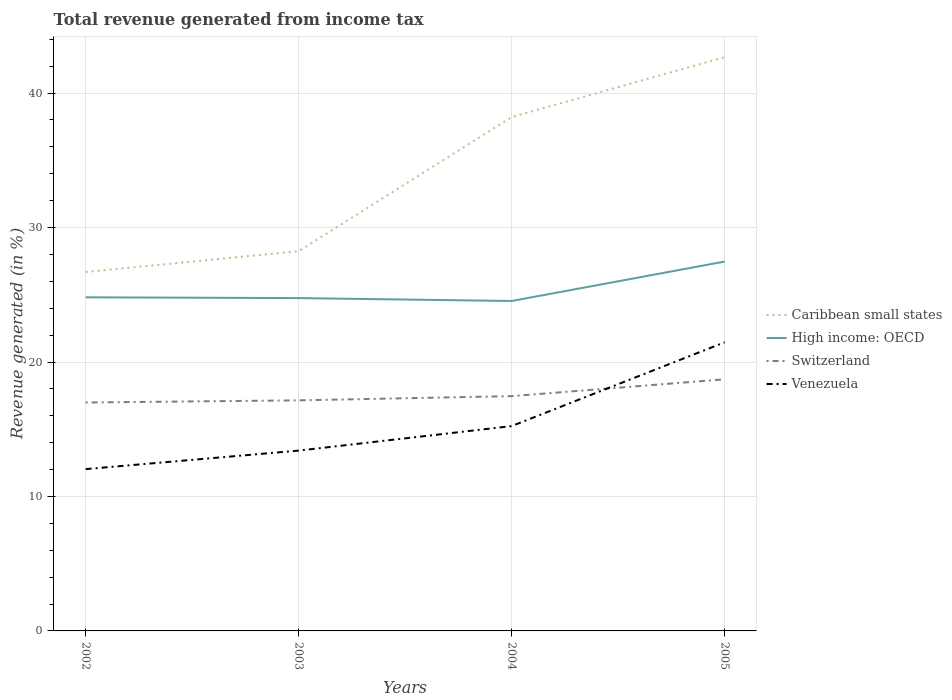How many different coloured lines are there?
Give a very brief answer. 4. Is the number of lines equal to the number of legend labels?
Ensure brevity in your answer.  Yes. Across all years, what is the maximum total revenue generated in Switzerland?
Offer a terse response. 16.99. What is the total total revenue generated in Venezuela in the graph?
Keep it short and to the point. -6.23. What is the difference between the highest and the second highest total revenue generated in Caribbean small states?
Offer a terse response. 15.98. Are the values on the major ticks of Y-axis written in scientific E-notation?
Your answer should be compact. No. Does the graph contain any zero values?
Your answer should be compact. No. Does the graph contain grids?
Give a very brief answer. Yes. How many legend labels are there?
Make the answer very short. 4. What is the title of the graph?
Your answer should be compact. Total revenue generated from income tax. Does "Mauritania" appear as one of the legend labels in the graph?
Your answer should be very brief. No. What is the label or title of the X-axis?
Provide a short and direct response. Years. What is the label or title of the Y-axis?
Keep it short and to the point. Revenue generated (in %). What is the Revenue generated (in %) in Caribbean small states in 2002?
Make the answer very short. 26.7. What is the Revenue generated (in %) in High income: OECD in 2002?
Make the answer very short. 24.81. What is the Revenue generated (in %) of Switzerland in 2002?
Ensure brevity in your answer.  16.99. What is the Revenue generated (in %) in Venezuela in 2002?
Give a very brief answer. 12.03. What is the Revenue generated (in %) of Caribbean small states in 2003?
Provide a succinct answer. 28.24. What is the Revenue generated (in %) in High income: OECD in 2003?
Offer a terse response. 24.75. What is the Revenue generated (in %) of Switzerland in 2003?
Ensure brevity in your answer.  17.15. What is the Revenue generated (in %) of Venezuela in 2003?
Offer a terse response. 13.41. What is the Revenue generated (in %) in Caribbean small states in 2004?
Ensure brevity in your answer.  38.22. What is the Revenue generated (in %) of High income: OECD in 2004?
Keep it short and to the point. 24.54. What is the Revenue generated (in %) of Switzerland in 2004?
Offer a very short reply. 17.46. What is the Revenue generated (in %) in Venezuela in 2004?
Provide a succinct answer. 15.23. What is the Revenue generated (in %) in Caribbean small states in 2005?
Provide a succinct answer. 42.67. What is the Revenue generated (in %) in High income: OECD in 2005?
Your response must be concise. 27.47. What is the Revenue generated (in %) of Switzerland in 2005?
Give a very brief answer. 18.71. What is the Revenue generated (in %) in Venezuela in 2005?
Your answer should be very brief. 21.46. Across all years, what is the maximum Revenue generated (in %) in Caribbean small states?
Make the answer very short. 42.67. Across all years, what is the maximum Revenue generated (in %) of High income: OECD?
Offer a terse response. 27.47. Across all years, what is the maximum Revenue generated (in %) of Switzerland?
Provide a succinct answer. 18.71. Across all years, what is the maximum Revenue generated (in %) in Venezuela?
Make the answer very short. 21.46. Across all years, what is the minimum Revenue generated (in %) of Caribbean small states?
Your response must be concise. 26.7. Across all years, what is the minimum Revenue generated (in %) of High income: OECD?
Make the answer very short. 24.54. Across all years, what is the minimum Revenue generated (in %) of Switzerland?
Your answer should be compact. 16.99. Across all years, what is the minimum Revenue generated (in %) in Venezuela?
Keep it short and to the point. 12.03. What is the total Revenue generated (in %) of Caribbean small states in the graph?
Your answer should be compact. 135.83. What is the total Revenue generated (in %) of High income: OECD in the graph?
Give a very brief answer. 101.57. What is the total Revenue generated (in %) in Switzerland in the graph?
Give a very brief answer. 70.31. What is the total Revenue generated (in %) of Venezuela in the graph?
Your answer should be compact. 62.14. What is the difference between the Revenue generated (in %) in Caribbean small states in 2002 and that in 2003?
Your answer should be very brief. -1.55. What is the difference between the Revenue generated (in %) of High income: OECD in 2002 and that in 2003?
Ensure brevity in your answer.  0.06. What is the difference between the Revenue generated (in %) in Switzerland in 2002 and that in 2003?
Make the answer very short. -0.16. What is the difference between the Revenue generated (in %) in Venezuela in 2002 and that in 2003?
Ensure brevity in your answer.  -1.38. What is the difference between the Revenue generated (in %) of Caribbean small states in 2002 and that in 2004?
Your answer should be very brief. -11.52. What is the difference between the Revenue generated (in %) of High income: OECD in 2002 and that in 2004?
Give a very brief answer. 0.27. What is the difference between the Revenue generated (in %) in Switzerland in 2002 and that in 2004?
Your response must be concise. -0.47. What is the difference between the Revenue generated (in %) of Venezuela in 2002 and that in 2004?
Offer a very short reply. -3.2. What is the difference between the Revenue generated (in %) in Caribbean small states in 2002 and that in 2005?
Your answer should be very brief. -15.98. What is the difference between the Revenue generated (in %) in High income: OECD in 2002 and that in 2005?
Ensure brevity in your answer.  -2.66. What is the difference between the Revenue generated (in %) in Switzerland in 2002 and that in 2005?
Offer a very short reply. -1.72. What is the difference between the Revenue generated (in %) in Venezuela in 2002 and that in 2005?
Ensure brevity in your answer.  -9.43. What is the difference between the Revenue generated (in %) in Caribbean small states in 2003 and that in 2004?
Your answer should be very brief. -9.98. What is the difference between the Revenue generated (in %) of High income: OECD in 2003 and that in 2004?
Keep it short and to the point. 0.22. What is the difference between the Revenue generated (in %) of Switzerland in 2003 and that in 2004?
Give a very brief answer. -0.31. What is the difference between the Revenue generated (in %) in Venezuela in 2003 and that in 2004?
Your answer should be compact. -1.82. What is the difference between the Revenue generated (in %) in Caribbean small states in 2003 and that in 2005?
Provide a succinct answer. -14.43. What is the difference between the Revenue generated (in %) of High income: OECD in 2003 and that in 2005?
Provide a succinct answer. -2.72. What is the difference between the Revenue generated (in %) of Switzerland in 2003 and that in 2005?
Make the answer very short. -1.56. What is the difference between the Revenue generated (in %) in Venezuela in 2003 and that in 2005?
Your answer should be very brief. -8.05. What is the difference between the Revenue generated (in %) of Caribbean small states in 2004 and that in 2005?
Offer a very short reply. -4.45. What is the difference between the Revenue generated (in %) of High income: OECD in 2004 and that in 2005?
Your answer should be very brief. -2.93. What is the difference between the Revenue generated (in %) of Switzerland in 2004 and that in 2005?
Provide a succinct answer. -1.25. What is the difference between the Revenue generated (in %) in Venezuela in 2004 and that in 2005?
Your answer should be very brief. -6.23. What is the difference between the Revenue generated (in %) in Caribbean small states in 2002 and the Revenue generated (in %) in High income: OECD in 2003?
Give a very brief answer. 1.94. What is the difference between the Revenue generated (in %) in Caribbean small states in 2002 and the Revenue generated (in %) in Switzerland in 2003?
Ensure brevity in your answer.  9.55. What is the difference between the Revenue generated (in %) of Caribbean small states in 2002 and the Revenue generated (in %) of Venezuela in 2003?
Give a very brief answer. 13.28. What is the difference between the Revenue generated (in %) in High income: OECD in 2002 and the Revenue generated (in %) in Switzerland in 2003?
Offer a very short reply. 7.66. What is the difference between the Revenue generated (in %) in High income: OECD in 2002 and the Revenue generated (in %) in Venezuela in 2003?
Ensure brevity in your answer.  11.4. What is the difference between the Revenue generated (in %) of Switzerland in 2002 and the Revenue generated (in %) of Venezuela in 2003?
Give a very brief answer. 3.58. What is the difference between the Revenue generated (in %) in Caribbean small states in 2002 and the Revenue generated (in %) in High income: OECD in 2004?
Give a very brief answer. 2.16. What is the difference between the Revenue generated (in %) of Caribbean small states in 2002 and the Revenue generated (in %) of Switzerland in 2004?
Offer a very short reply. 9.23. What is the difference between the Revenue generated (in %) in Caribbean small states in 2002 and the Revenue generated (in %) in Venezuela in 2004?
Give a very brief answer. 11.46. What is the difference between the Revenue generated (in %) in High income: OECD in 2002 and the Revenue generated (in %) in Switzerland in 2004?
Ensure brevity in your answer.  7.35. What is the difference between the Revenue generated (in %) of High income: OECD in 2002 and the Revenue generated (in %) of Venezuela in 2004?
Offer a very short reply. 9.58. What is the difference between the Revenue generated (in %) in Switzerland in 2002 and the Revenue generated (in %) in Venezuela in 2004?
Your response must be concise. 1.75. What is the difference between the Revenue generated (in %) of Caribbean small states in 2002 and the Revenue generated (in %) of High income: OECD in 2005?
Offer a very short reply. -0.77. What is the difference between the Revenue generated (in %) of Caribbean small states in 2002 and the Revenue generated (in %) of Switzerland in 2005?
Offer a very short reply. 7.98. What is the difference between the Revenue generated (in %) in Caribbean small states in 2002 and the Revenue generated (in %) in Venezuela in 2005?
Make the answer very short. 5.23. What is the difference between the Revenue generated (in %) in High income: OECD in 2002 and the Revenue generated (in %) in Switzerland in 2005?
Offer a terse response. 6.1. What is the difference between the Revenue generated (in %) of High income: OECD in 2002 and the Revenue generated (in %) of Venezuela in 2005?
Make the answer very short. 3.35. What is the difference between the Revenue generated (in %) of Switzerland in 2002 and the Revenue generated (in %) of Venezuela in 2005?
Keep it short and to the point. -4.48. What is the difference between the Revenue generated (in %) in Caribbean small states in 2003 and the Revenue generated (in %) in High income: OECD in 2004?
Provide a succinct answer. 3.7. What is the difference between the Revenue generated (in %) of Caribbean small states in 2003 and the Revenue generated (in %) of Switzerland in 2004?
Your answer should be compact. 10.78. What is the difference between the Revenue generated (in %) of Caribbean small states in 2003 and the Revenue generated (in %) of Venezuela in 2004?
Make the answer very short. 13.01. What is the difference between the Revenue generated (in %) in High income: OECD in 2003 and the Revenue generated (in %) in Switzerland in 2004?
Keep it short and to the point. 7.29. What is the difference between the Revenue generated (in %) of High income: OECD in 2003 and the Revenue generated (in %) of Venezuela in 2004?
Your response must be concise. 9.52. What is the difference between the Revenue generated (in %) in Switzerland in 2003 and the Revenue generated (in %) in Venezuela in 2004?
Offer a very short reply. 1.91. What is the difference between the Revenue generated (in %) in Caribbean small states in 2003 and the Revenue generated (in %) in High income: OECD in 2005?
Provide a succinct answer. 0.77. What is the difference between the Revenue generated (in %) of Caribbean small states in 2003 and the Revenue generated (in %) of Switzerland in 2005?
Offer a terse response. 9.53. What is the difference between the Revenue generated (in %) in Caribbean small states in 2003 and the Revenue generated (in %) in Venezuela in 2005?
Give a very brief answer. 6.78. What is the difference between the Revenue generated (in %) of High income: OECD in 2003 and the Revenue generated (in %) of Switzerland in 2005?
Keep it short and to the point. 6.04. What is the difference between the Revenue generated (in %) of High income: OECD in 2003 and the Revenue generated (in %) of Venezuela in 2005?
Offer a terse response. 3.29. What is the difference between the Revenue generated (in %) of Switzerland in 2003 and the Revenue generated (in %) of Venezuela in 2005?
Make the answer very short. -4.32. What is the difference between the Revenue generated (in %) in Caribbean small states in 2004 and the Revenue generated (in %) in High income: OECD in 2005?
Offer a very short reply. 10.75. What is the difference between the Revenue generated (in %) of Caribbean small states in 2004 and the Revenue generated (in %) of Switzerland in 2005?
Provide a succinct answer. 19.5. What is the difference between the Revenue generated (in %) in Caribbean small states in 2004 and the Revenue generated (in %) in Venezuela in 2005?
Make the answer very short. 16.75. What is the difference between the Revenue generated (in %) in High income: OECD in 2004 and the Revenue generated (in %) in Switzerland in 2005?
Your answer should be compact. 5.82. What is the difference between the Revenue generated (in %) in High income: OECD in 2004 and the Revenue generated (in %) in Venezuela in 2005?
Your answer should be very brief. 3.07. What is the difference between the Revenue generated (in %) of Switzerland in 2004 and the Revenue generated (in %) of Venezuela in 2005?
Your answer should be compact. -4. What is the average Revenue generated (in %) of Caribbean small states per year?
Ensure brevity in your answer.  33.96. What is the average Revenue generated (in %) of High income: OECD per year?
Provide a short and direct response. 25.39. What is the average Revenue generated (in %) in Switzerland per year?
Keep it short and to the point. 17.58. What is the average Revenue generated (in %) in Venezuela per year?
Make the answer very short. 15.54. In the year 2002, what is the difference between the Revenue generated (in %) of Caribbean small states and Revenue generated (in %) of High income: OECD?
Your answer should be very brief. 1.88. In the year 2002, what is the difference between the Revenue generated (in %) of Caribbean small states and Revenue generated (in %) of Switzerland?
Offer a terse response. 9.71. In the year 2002, what is the difference between the Revenue generated (in %) of Caribbean small states and Revenue generated (in %) of Venezuela?
Make the answer very short. 14.66. In the year 2002, what is the difference between the Revenue generated (in %) in High income: OECD and Revenue generated (in %) in Switzerland?
Provide a short and direct response. 7.82. In the year 2002, what is the difference between the Revenue generated (in %) in High income: OECD and Revenue generated (in %) in Venezuela?
Provide a succinct answer. 12.78. In the year 2002, what is the difference between the Revenue generated (in %) in Switzerland and Revenue generated (in %) in Venezuela?
Offer a very short reply. 4.95. In the year 2003, what is the difference between the Revenue generated (in %) in Caribbean small states and Revenue generated (in %) in High income: OECD?
Ensure brevity in your answer.  3.49. In the year 2003, what is the difference between the Revenue generated (in %) in Caribbean small states and Revenue generated (in %) in Switzerland?
Make the answer very short. 11.09. In the year 2003, what is the difference between the Revenue generated (in %) of Caribbean small states and Revenue generated (in %) of Venezuela?
Your response must be concise. 14.83. In the year 2003, what is the difference between the Revenue generated (in %) of High income: OECD and Revenue generated (in %) of Switzerland?
Offer a terse response. 7.61. In the year 2003, what is the difference between the Revenue generated (in %) in High income: OECD and Revenue generated (in %) in Venezuela?
Your response must be concise. 11.34. In the year 2003, what is the difference between the Revenue generated (in %) in Switzerland and Revenue generated (in %) in Venezuela?
Give a very brief answer. 3.74. In the year 2004, what is the difference between the Revenue generated (in %) of Caribbean small states and Revenue generated (in %) of High income: OECD?
Your response must be concise. 13.68. In the year 2004, what is the difference between the Revenue generated (in %) in Caribbean small states and Revenue generated (in %) in Switzerland?
Give a very brief answer. 20.75. In the year 2004, what is the difference between the Revenue generated (in %) in Caribbean small states and Revenue generated (in %) in Venezuela?
Your answer should be compact. 22.98. In the year 2004, what is the difference between the Revenue generated (in %) of High income: OECD and Revenue generated (in %) of Switzerland?
Ensure brevity in your answer.  7.07. In the year 2004, what is the difference between the Revenue generated (in %) of High income: OECD and Revenue generated (in %) of Venezuela?
Give a very brief answer. 9.3. In the year 2004, what is the difference between the Revenue generated (in %) in Switzerland and Revenue generated (in %) in Venezuela?
Make the answer very short. 2.23. In the year 2005, what is the difference between the Revenue generated (in %) in Caribbean small states and Revenue generated (in %) in High income: OECD?
Keep it short and to the point. 15.2. In the year 2005, what is the difference between the Revenue generated (in %) of Caribbean small states and Revenue generated (in %) of Switzerland?
Offer a very short reply. 23.96. In the year 2005, what is the difference between the Revenue generated (in %) of Caribbean small states and Revenue generated (in %) of Venezuela?
Provide a short and direct response. 21.21. In the year 2005, what is the difference between the Revenue generated (in %) in High income: OECD and Revenue generated (in %) in Switzerland?
Keep it short and to the point. 8.76. In the year 2005, what is the difference between the Revenue generated (in %) of High income: OECD and Revenue generated (in %) of Venezuela?
Ensure brevity in your answer.  6. In the year 2005, what is the difference between the Revenue generated (in %) of Switzerland and Revenue generated (in %) of Venezuela?
Offer a very short reply. -2.75. What is the ratio of the Revenue generated (in %) of Caribbean small states in 2002 to that in 2003?
Your answer should be very brief. 0.95. What is the ratio of the Revenue generated (in %) in High income: OECD in 2002 to that in 2003?
Make the answer very short. 1. What is the ratio of the Revenue generated (in %) of Switzerland in 2002 to that in 2003?
Ensure brevity in your answer.  0.99. What is the ratio of the Revenue generated (in %) in Venezuela in 2002 to that in 2003?
Provide a succinct answer. 0.9. What is the ratio of the Revenue generated (in %) in Caribbean small states in 2002 to that in 2004?
Your answer should be compact. 0.7. What is the ratio of the Revenue generated (in %) in High income: OECD in 2002 to that in 2004?
Offer a terse response. 1.01. What is the ratio of the Revenue generated (in %) in Switzerland in 2002 to that in 2004?
Offer a terse response. 0.97. What is the ratio of the Revenue generated (in %) of Venezuela in 2002 to that in 2004?
Keep it short and to the point. 0.79. What is the ratio of the Revenue generated (in %) of Caribbean small states in 2002 to that in 2005?
Your answer should be very brief. 0.63. What is the ratio of the Revenue generated (in %) of High income: OECD in 2002 to that in 2005?
Give a very brief answer. 0.9. What is the ratio of the Revenue generated (in %) of Switzerland in 2002 to that in 2005?
Ensure brevity in your answer.  0.91. What is the ratio of the Revenue generated (in %) of Venezuela in 2002 to that in 2005?
Offer a very short reply. 0.56. What is the ratio of the Revenue generated (in %) of Caribbean small states in 2003 to that in 2004?
Your answer should be very brief. 0.74. What is the ratio of the Revenue generated (in %) of High income: OECD in 2003 to that in 2004?
Provide a succinct answer. 1.01. What is the ratio of the Revenue generated (in %) in Venezuela in 2003 to that in 2004?
Offer a very short reply. 0.88. What is the ratio of the Revenue generated (in %) of Caribbean small states in 2003 to that in 2005?
Offer a very short reply. 0.66. What is the ratio of the Revenue generated (in %) of High income: OECD in 2003 to that in 2005?
Offer a very short reply. 0.9. What is the ratio of the Revenue generated (in %) of Switzerland in 2003 to that in 2005?
Your answer should be very brief. 0.92. What is the ratio of the Revenue generated (in %) of Venezuela in 2003 to that in 2005?
Your answer should be very brief. 0.62. What is the ratio of the Revenue generated (in %) in Caribbean small states in 2004 to that in 2005?
Offer a terse response. 0.9. What is the ratio of the Revenue generated (in %) of High income: OECD in 2004 to that in 2005?
Your response must be concise. 0.89. What is the ratio of the Revenue generated (in %) of Switzerland in 2004 to that in 2005?
Give a very brief answer. 0.93. What is the ratio of the Revenue generated (in %) in Venezuela in 2004 to that in 2005?
Provide a succinct answer. 0.71. What is the difference between the highest and the second highest Revenue generated (in %) in Caribbean small states?
Your answer should be compact. 4.45. What is the difference between the highest and the second highest Revenue generated (in %) of High income: OECD?
Give a very brief answer. 2.66. What is the difference between the highest and the second highest Revenue generated (in %) in Switzerland?
Your answer should be compact. 1.25. What is the difference between the highest and the second highest Revenue generated (in %) of Venezuela?
Keep it short and to the point. 6.23. What is the difference between the highest and the lowest Revenue generated (in %) in Caribbean small states?
Offer a terse response. 15.98. What is the difference between the highest and the lowest Revenue generated (in %) of High income: OECD?
Provide a succinct answer. 2.93. What is the difference between the highest and the lowest Revenue generated (in %) in Switzerland?
Your answer should be very brief. 1.72. What is the difference between the highest and the lowest Revenue generated (in %) of Venezuela?
Your response must be concise. 9.43. 